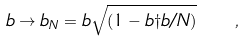Convert formula to latex. <formula><loc_0><loc_0><loc_500><loc_500>b \to b _ { N } = b \sqrt { ( 1 - b \dag b / N ) } \quad ,</formula> 